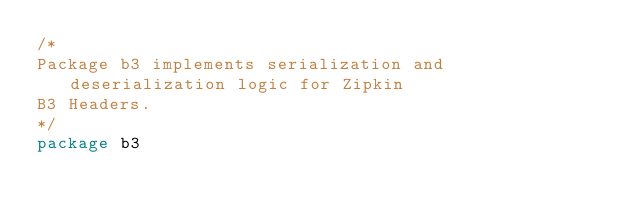Convert code to text. <code><loc_0><loc_0><loc_500><loc_500><_Go_>/*
Package b3 implements serialization and deserialization logic for Zipkin
B3 Headers.
*/
package b3
</code> 